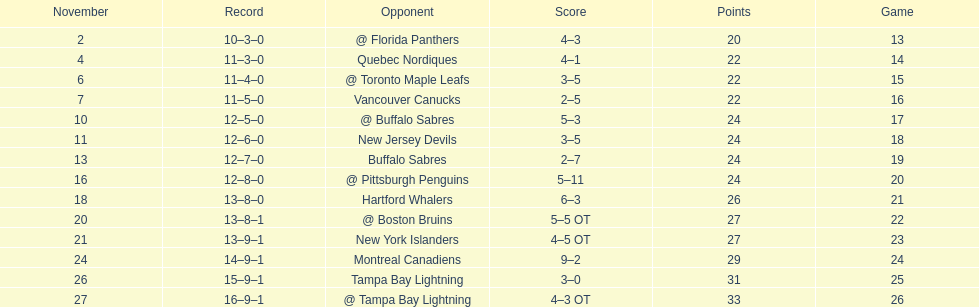What was the number of wins the philadelphia flyers had? 35. 